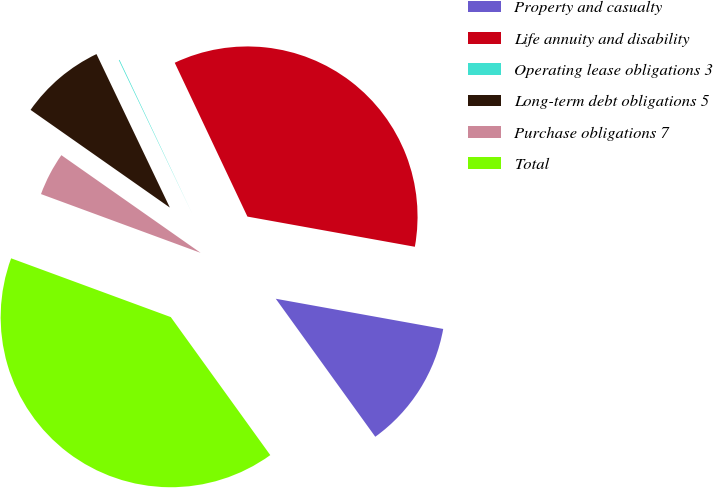Convert chart. <chart><loc_0><loc_0><loc_500><loc_500><pie_chart><fcel>Property and casualty<fcel>Life annuity and disability<fcel>Operating lease obligations 3<fcel>Long-term debt obligations 5<fcel>Purchase obligations 7<fcel>Total<nl><fcel>12.22%<fcel>34.87%<fcel>0.07%<fcel>8.17%<fcel>4.12%<fcel>40.56%<nl></chart> 